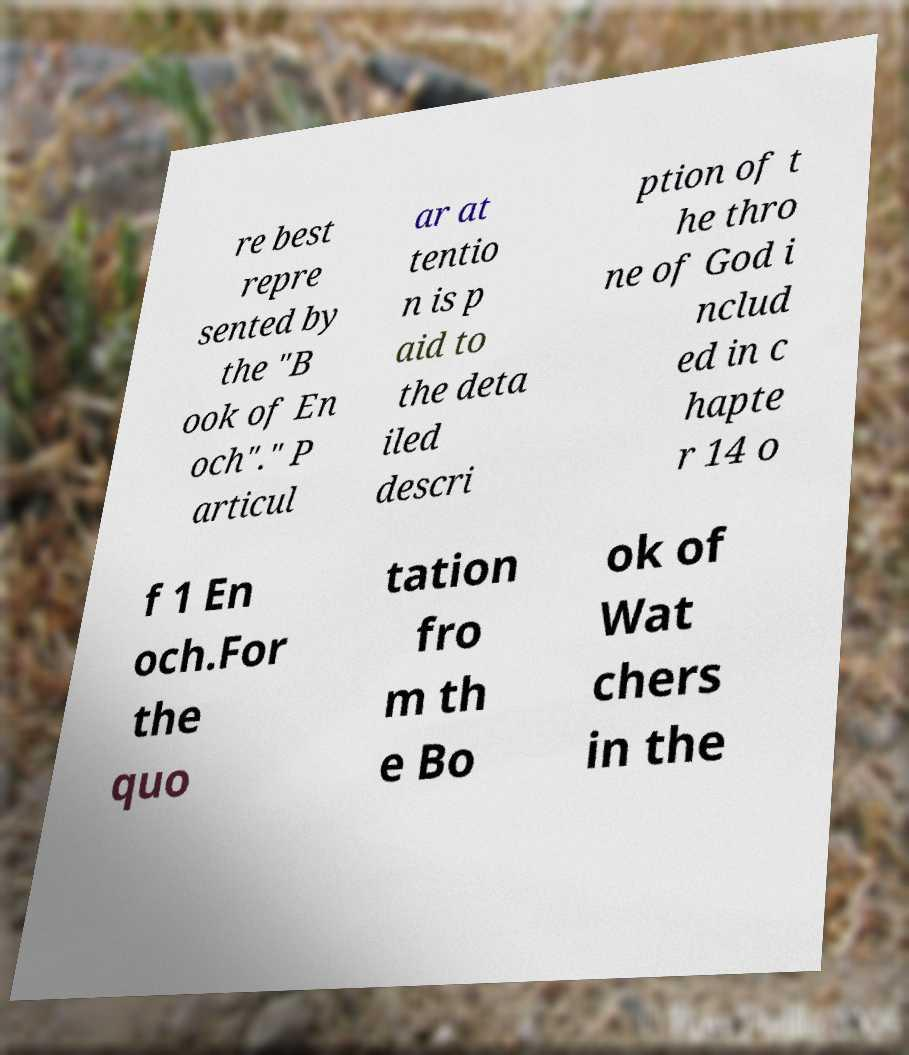There's text embedded in this image that I need extracted. Can you transcribe it verbatim? re best repre sented by the "B ook of En och"." P articul ar at tentio n is p aid to the deta iled descri ption of t he thro ne of God i nclud ed in c hapte r 14 o f 1 En och.For the quo tation fro m th e Bo ok of Wat chers in the 